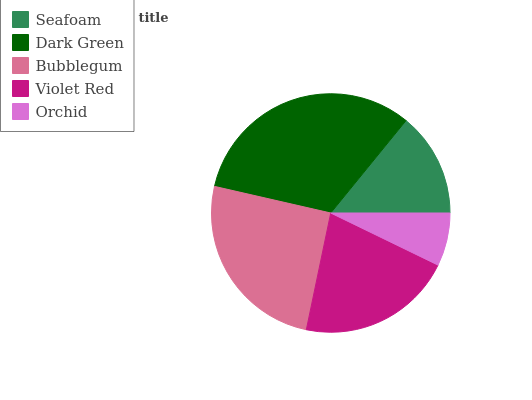Is Orchid the minimum?
Answer yes or no. Yes. Is Dark Green the maximum?
Answer yes or no. Yes. Is Bubblegum the minimum?
Answer yes or no. No. Is Bubblegum the maximum?
Answer yes or no. No. Is Dark Green greater than Bubblegum?
Answer yes or no. Yes. Is Bubblegum less than Dark Green?
Answer yes or no. Yes. Is Bubblegum greater than Dark Green?
Answer yes or no. No. Is Dark Green less than Bubblegum?
Answer yes or no. No. Is Violet Red the high median?
Answer yes or no. Yes. Is Violet Red the low median?
Answer yes or no. Yes. Is Dark Green the high median?
Answer yes or no. No. Is Orchid the low median?
Answer yes or no. No. 